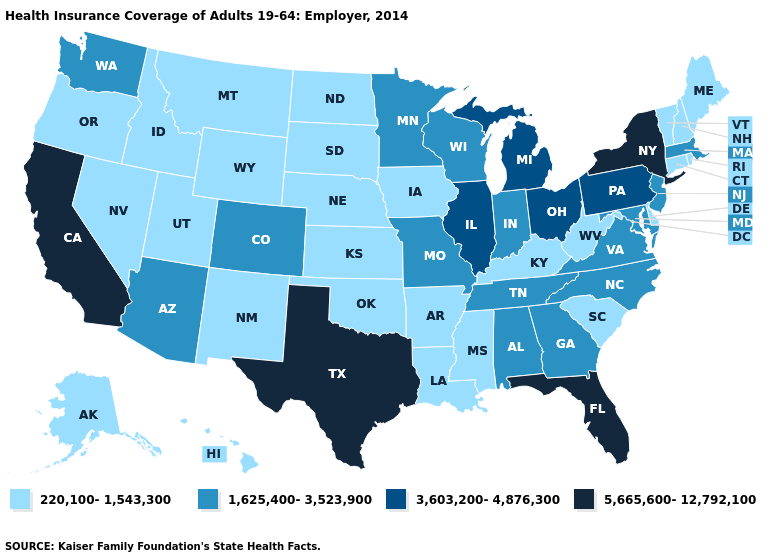Which states hav the highest value in the West?
Short answer required. California. What is the highest value in the West ?
Quick response, please. 5,665,600-12,792,100. Does Texas have the highest value in the USA?
Concise answer only. Yes. Does Texas have the lowest value in the USA?
Write a very short answer. No. Among the states that border Rhode Island , which have the highest value?
Short answer required. Massachusetts. What is the value of Iowa?
Quick response, please. 220,100-1,543,300. How many symbols are there in the legend?
Write a very short answer. 4. Which states have the lowest value in the USA?
Keep it brief. Alaska, Arkansas, Connecticut, Delaware, Hawaii, Idaho, Iowa, Kansas, Kentucky, Louisiana, Maine, Mississippi, Montana, Nebraska, Nevada, New Hampshire, New Mexico, North Dakota, Oklahoma, Oregon, Rhode Island, South Carolina, South Dakota, Utah, Vermont, West Virginia, Wyoming. What is the value of Mississippi?
Answer briefly. 220,100-1,543,300. Name the states that have a value in the range 220,100-1,543,300?
Be succinct. Alaska, Arkansas, Connecticut, Delaware, Hawaii, Idaho, Iowa, Kansas, Kentucky, Louisiana, Maine, Mississippi, Montana, Nebraska, Nevada, New Hampshire, New Mexico, North Dakota, Oklahoma, Oregon, Rhode Island, South Carolina, South Dakota, Utah, Vermont, West Virginia, Wyoming. Which states have the lowest value in the USA?
Quick response, please. Alaska, Arkansas, Connecticut, Delaware, Hawaii, Idaho, Iowa, Kansas, Kentucky, Louisiana, Maine, Mississippi, Montana, Nebraska, Nevada, New Hampshire, New Mexico, North Dakota, Oklahoma, Oregon, Rhode Island, South Carolina, South Dakota, Utah, Vermont, West Virginia, Wyoming. Does the first symbol in the legend represent the smallest category?
Concise answer only. Yes. Does Minnesota have the lowest value in the USA?
Write a very short answer. No. Does New York have the highest value in the USA?
Write a very short answer. Yes. What is the lowest value in the West?
Be succinct. 220,100-1,543,300. 